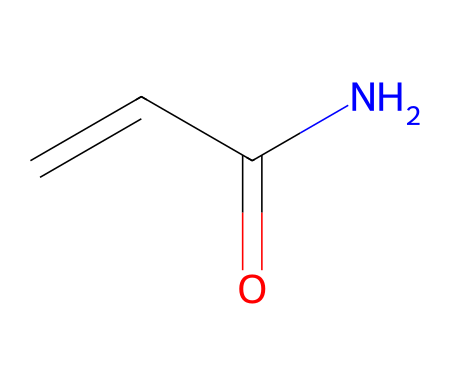What is the molecular formula of acrylamide? The molecular formula can be derived from the SMILES representation. Counting the number of each type of atom gives us C (3), H (5), N (1), and O (1), which combines to the formula C3H5NO.
Answer: C3H5NO How many carbon atoms are in acrylamide? By examining the SMILES, the 'C' characters denote carbon atoms. There are three 'C' symbols, confirming the presence of three carbon atoms.
Answer: 3 What functional group is present in acrylamide? The SMILES representation includes the 'C(=O)' part, indicating a carbonyl group, specifically an amide due to the adjacent nitrogen atom.
Answer: amide Is acrylamide a saturated or unsaturated compound? The presence of a double bond ('C=C') in the SMILES indicates that the compound has at least one double bond, making it unsaturated.
Answer: unsaturated What type of chemical reaction can acrylamide undergo to form polymers? Acrylamide can undergo polymerization due to the presence of a double bond, allowing it to react with other acrylamide molecules to form polyacrylamide.
Answer: polymerization What is the significance of acrylamide being classified as a monomer? As a monomer, acrylamide serves as a building block for larger polymers like polyacrylamide used in various applications, including water treatment and as a gel in electrophoresis.
Answer: building block Which isomeric form of acrylamide is typically referred to in food safety discussions? The isomeric form under discussion in food safety is the standard form represented by the given SMILES, which corresponds to the electrophilic properties of acrylamide during cooking at high temperatures.
Answer: standard form 